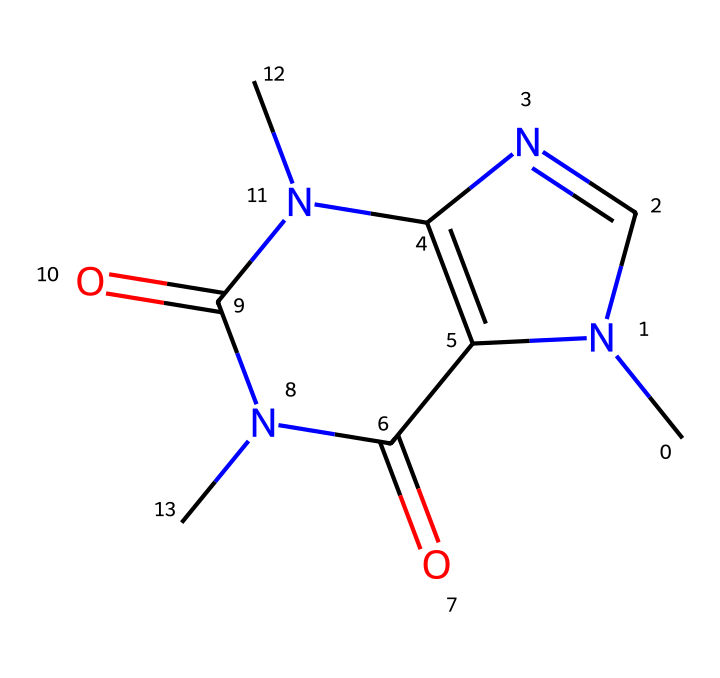What is the chemical name of this compound? The SMILES representation indicates the structure corresponds to caffeine, a well-known stimulant.
Answer: caffeine How many nitrogen atoms are present in the chemical structure? By analyzing the SMILES representation, we can identify the nitrogen (N) atoms, and there are four instances of nitrogen in the structure.
Answer: four What type of functional groups are present in caffeine? The SMILES representation shows carbonyl (C=O) and amine (N) functional groups. Carbonyl groups are typically involved in various chemical reactions, while amines can influence solubility and reactivity.
Answer: carbonyl and amine How many rings are present in the caffeine molecule? The SMILES reveals the presence of two fused rings in its structure, which can be seen where the lines create a cyclic structure.
Answer: two What effect does caffeine primarily have on cognitive function? Caffeine is known to enhance alertness and concentration due to its action as an antagonist of adenosine receptors in the brain, reducing fatigue and increasing arousal.
Answer: enhances alertness Which part of the molecule is crucial for its stimulant effect? The presence of nitrogen atoms in a cyclic structure makes it a xanthine derivative, which is essential for its stimulant activity by blocking adenosine.
Answer: nitrogen atoms What is the molecular formula of caffeine? Given the counted elements from the SMILES, the molecular composition consists of eight carbon (C) atoms, ten hydrogen (H) atoms, four nitrogen (N) atoms, and two oxygen (O) atoms, resulting in the formula C8H10N4O2.
Answer: C8H10N4O2 